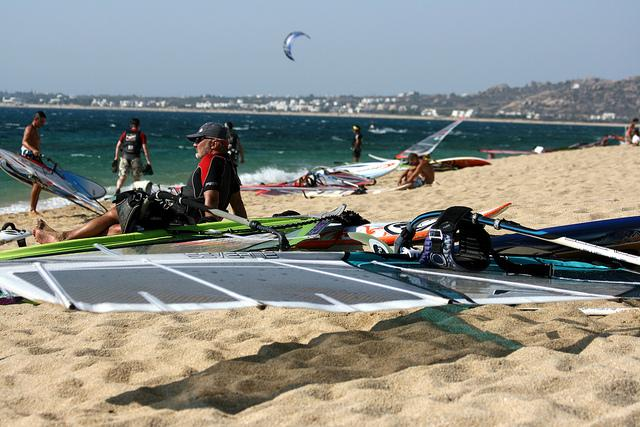Where is the person holding the sail seen here standing?

Choices:
A) whale's back
B) roadway
C) ocean
D) beach ocean 